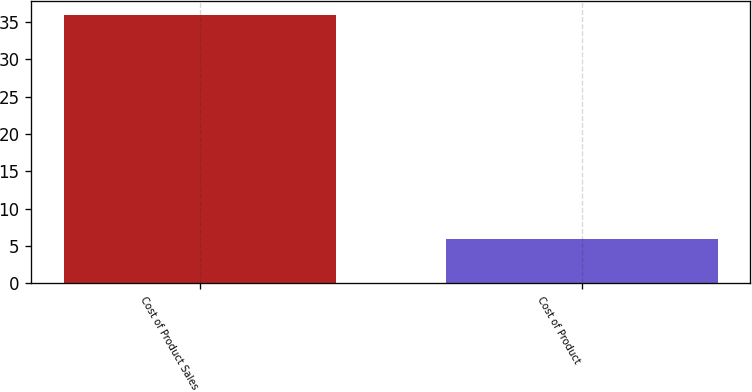Convert chart to OTSL. <chart><loc_0><loc_0><loc_500><loc_500><bar_chart><fcel>Cost of Product Sales<fcel>Cost of Product<nl><fcel>36<fcel>6<nl></chart> 